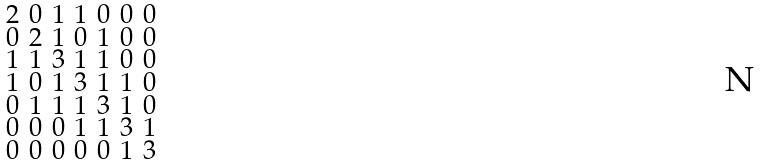Convert formula to latex. <formula><loc_0><loc_0><loc_500><loc_500>\begin{smallmatrix} 2 & 0 & 1 & 1 & 0 & 0 & 0 \\ 0 & 2 & 1 & 0 & 1 & 0 & 0 \\ 1 & 1 & 3 & 1 & 1 & 0 & 0 \\ 1 & 0 & 1 & 3 & 1 & 1 & 0 \\ 0 & 1 & 1 & 1 & 3 & 1 & 0 \\ 0 & 0 & 0 & 1 & 1 & 3 & 1 \\ 0 & 0 & 0 & 0 & 0 & 1 & 3 \end{smallmatrix}</formula> 